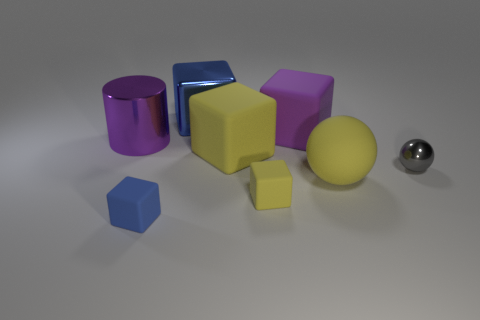Suppose the objects in the image were part of a children's learning program. What could be some educational activities involving these items? These objects could be used for several educational activities. For one, children could learn about 3D shapes and colors by identifying and naming each object. They could also practice counting the shapes or grouping them by color or type. Another activity could involve understanding spatial relationships, such as discussing which objects are in front of or behind others, or describing the various sizes of similar shapes. 